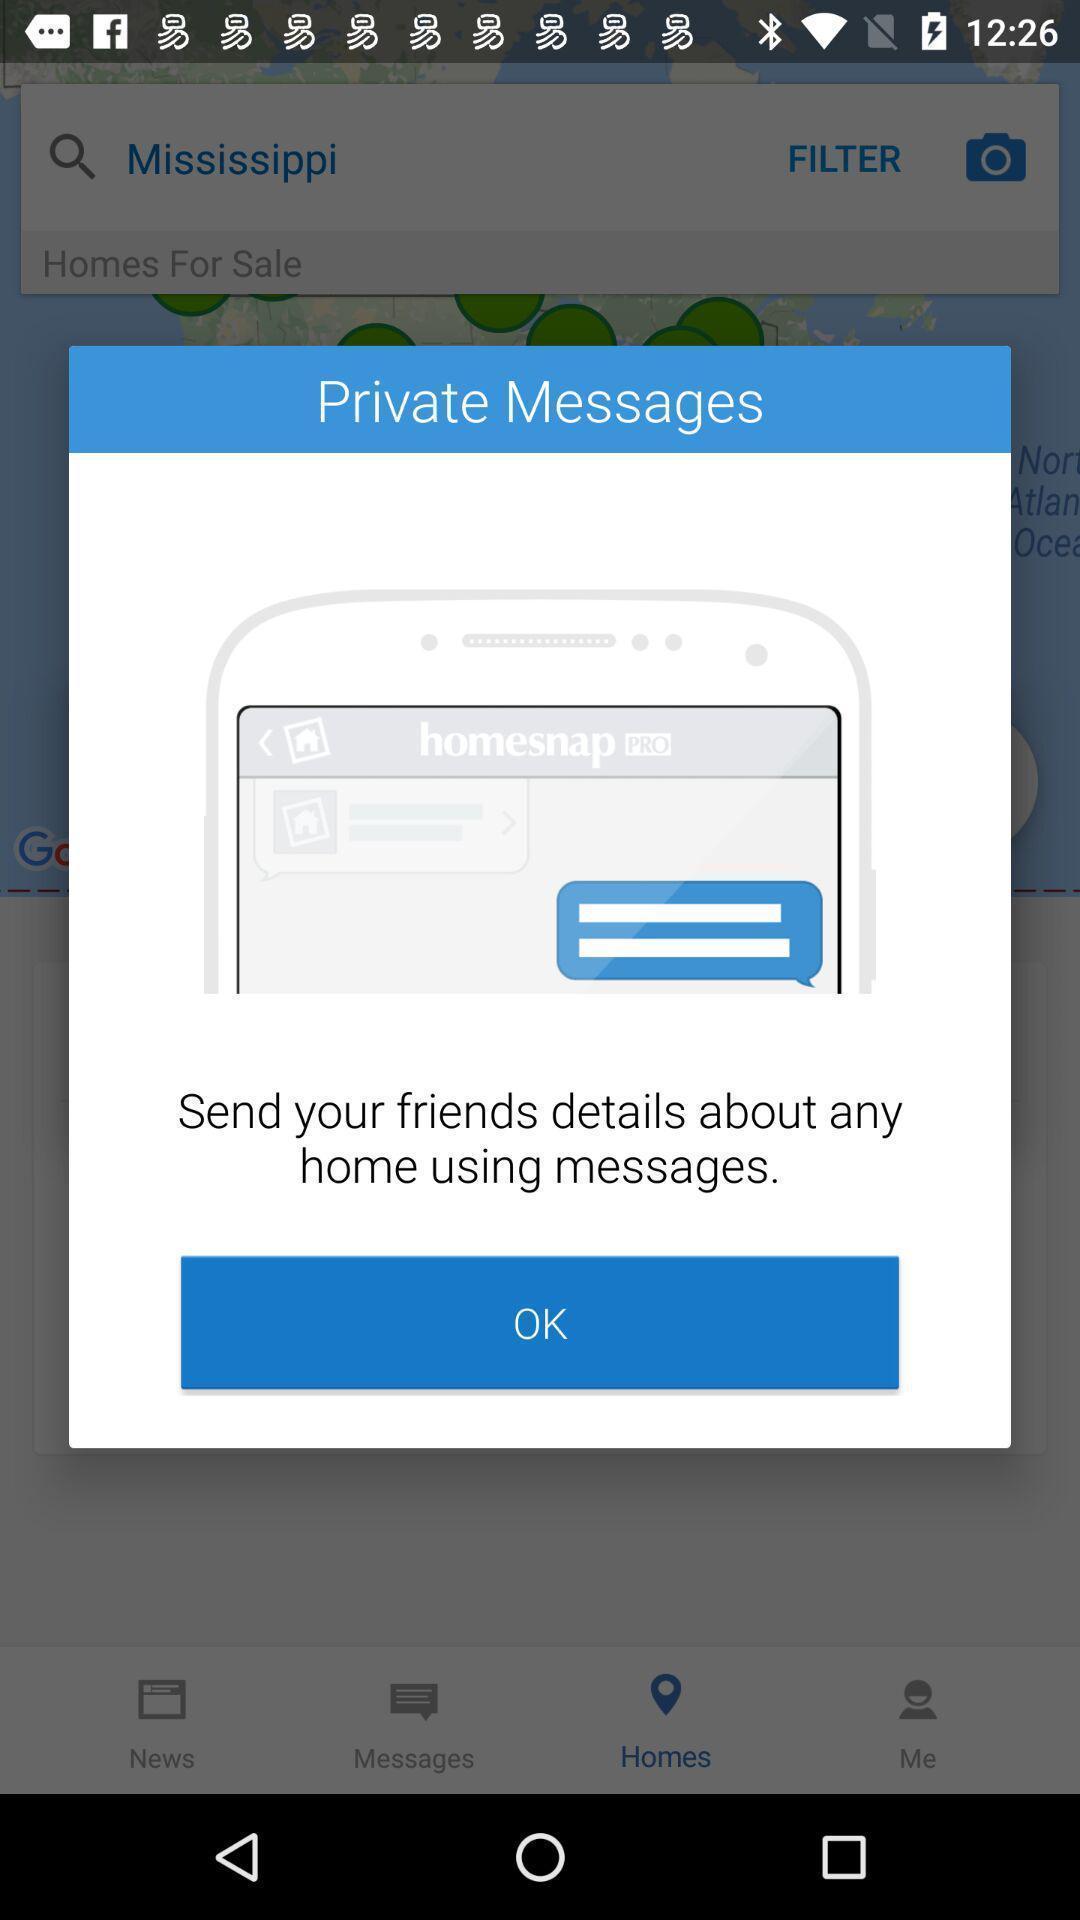Explain the elements present in this screenshot. Pop-up displaying the app information. 